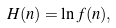<formula> <loc_0><loc_0><loc_500><loc_500>H ( n ) = \ln f ( n ) ,</formula> 